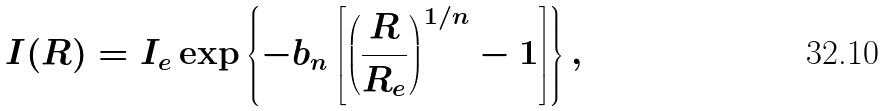Convert formula to latex. <formula><loc_0><loc_0><loc_500><loc_500>I ( R ) = I _ { e } \exp \left \{ - b _ { n } \left [ \left ( \frac { R } { R _ { e } } \right ) ^ { 1 / n } - 1 \right ] \right \} ,</formula> 